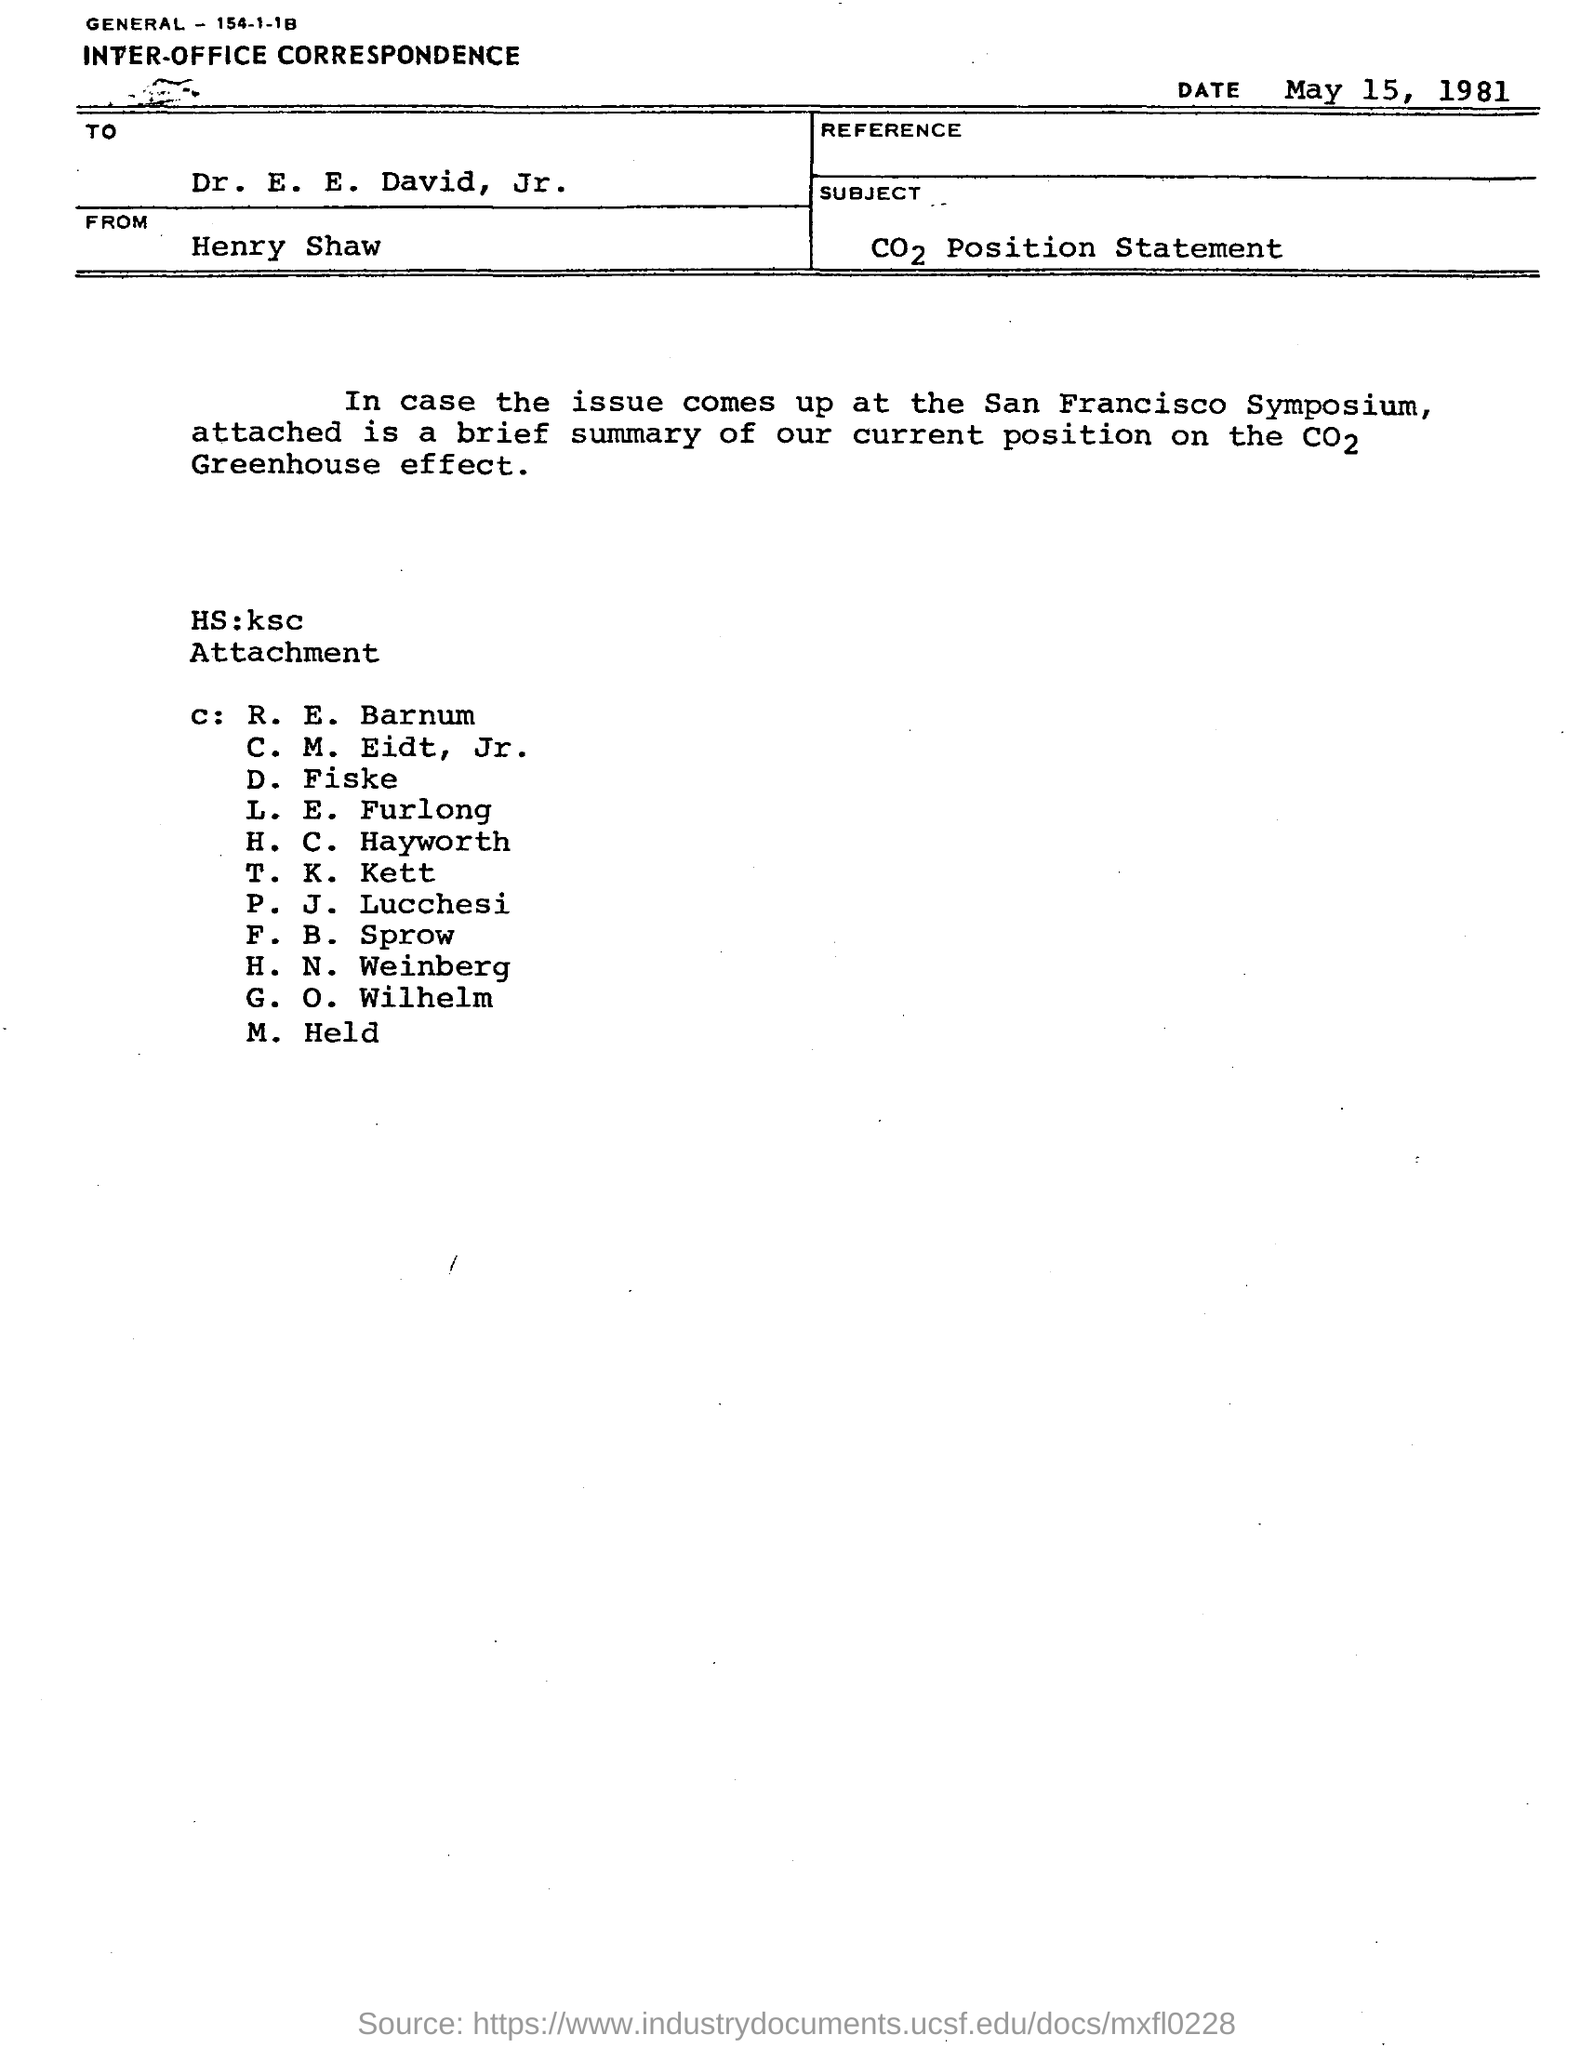When is the document dated?
Offer a very short reply. May 15, 1981. What type of documentation is this?
Give a very brief answer. INTER-OFFICE CORRESPONDENCE. To whom is the document addressed?
Your response must be concise. Dr. E. E. David, Jr. From whom is the document?
Offer a very short reply. Henry Shaw. 